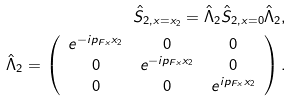<formula> <loc_0><loc_0><loc_500><loc_500>\hat { S } _ { 2 , x = x _ { 2 } } = \hat { \Lambda } _ { 2 } \hat { S } _ { 2 , x = 0 } \hat { \Lambda } _ { 2 } , \\ \hat { \Lambda } _ { 2 } = \left ( \begin{array} { c c c } e ^ { - i p _ { F x } x _ { 2 } } & 0 & 0 \\ 0 & e ^ { - i p _ { F x } x _ { 2 } } & 0 \\ 0 & 0 & e ^ { i p _ { F x } x _ { 2 } } \end{array} \right ) .</formula> 